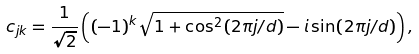Convert formula to latex. <formula><loc_0><loc_0><loc_500><loc_500>c _ { j k } = \frac { 1 } { \sqrt { 2 } } \left ( ( - 1 ) ^ { k } \sqrt { 1 + \cos ^ { 2 } ( 2 \pi j / d ) } - i \sin ( 2 \pi j / d ) \right ) ,</formula> 